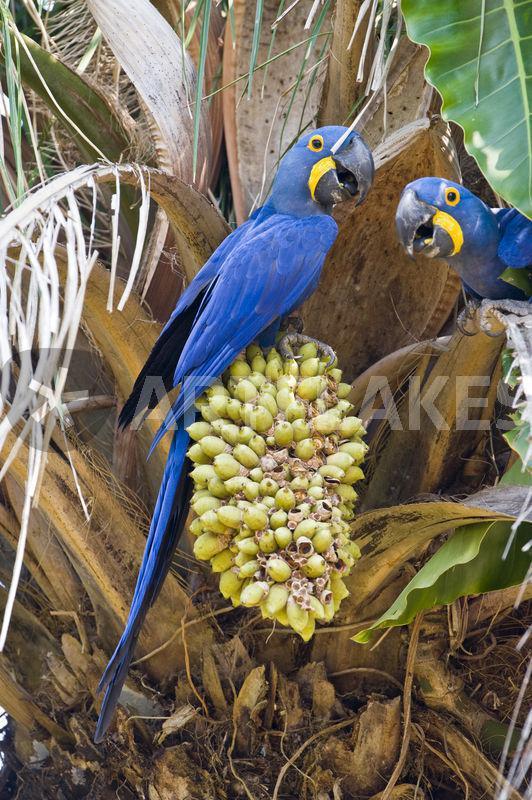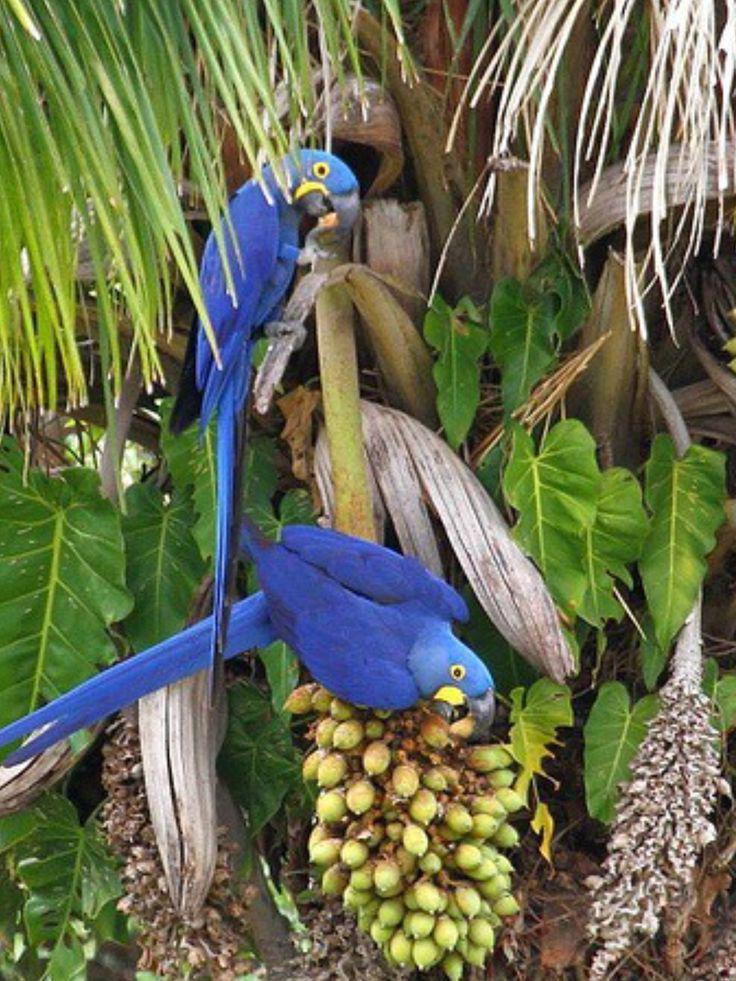The first image is the image on the left, the second image is the image on the right. Given the left and right images, does the statement "There are at most two birds." hold true? Answer yes or no. No. The first image is the image on the left, the second image is the image on the right. Examine the images to the left and right. Is the description "There are several parrots, definitely more than two." accurate? Answer yes or no. Yes. 